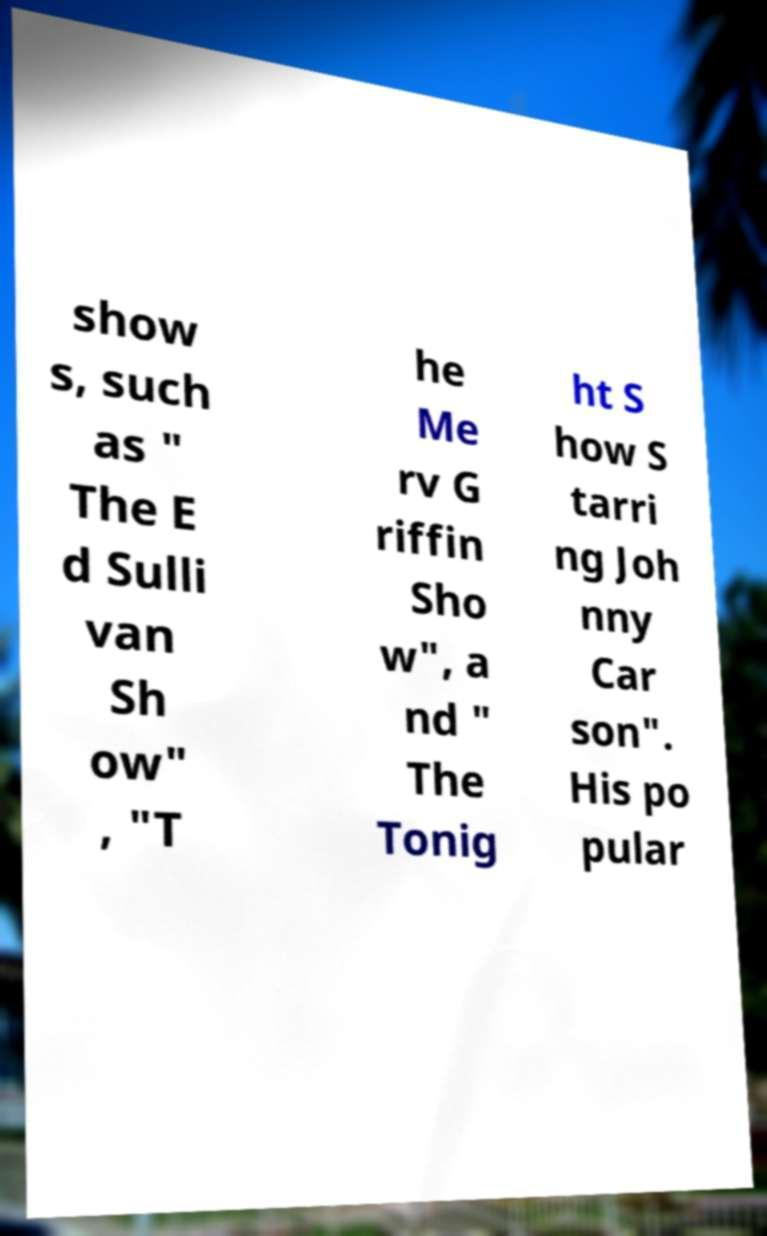For documentation purposes, I need the text within this image transcribed. Could you provide that? show s, such as " The E d Sulli van Sh ow" , "T he Me rv G riffin Sho w", a nd " The Tonig ht S how S tarri ng Joh nny Car son". His po pular 